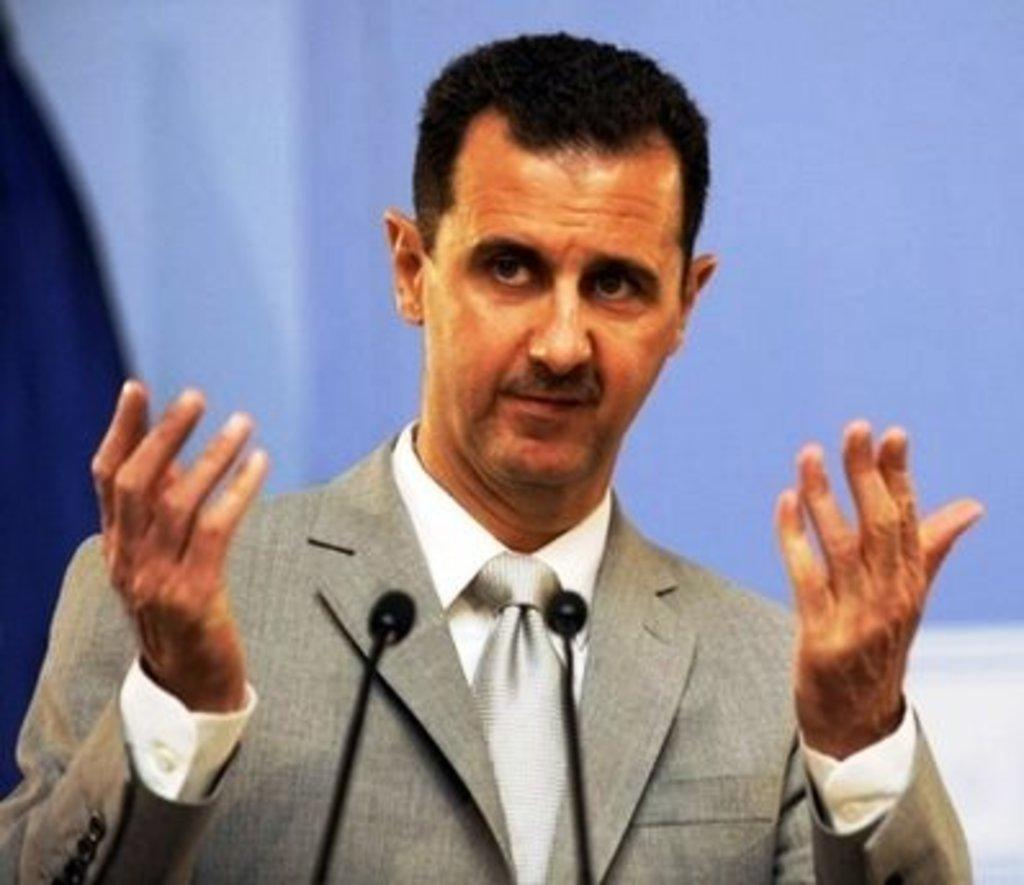Who is present in the image? There is a man in the image. What is the man wearing? The man is wearing a suit. In which direction is the man looking? The man is looking to the left side. What objects are in front of the man? There are two microphones in front of the man. Can you describe the background of the image? The background of the image is blurred. What type of umbrella is the man holding in the image? There is no umbrella present in the image. Can you describe the bee buzzing around the man's head in the image? There is no bee present in the image. 